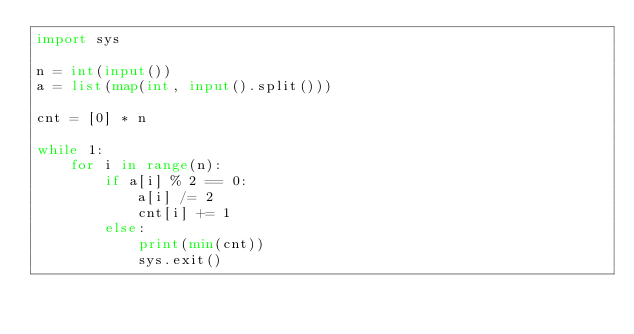Convert code to text. <code><loc_0><loc_0><loc_500><loc_500><_Python_>import sys

n = int(input())
a = list(map(int, input().split()))

cnt = [0] * n

while 1:
    for i in range(n):
        if a[i] % 2 == 0:
            a[i] /= 2
            cnt[i] += 1
        else:
            print(min(cnt))
            sys.exit()</code> 